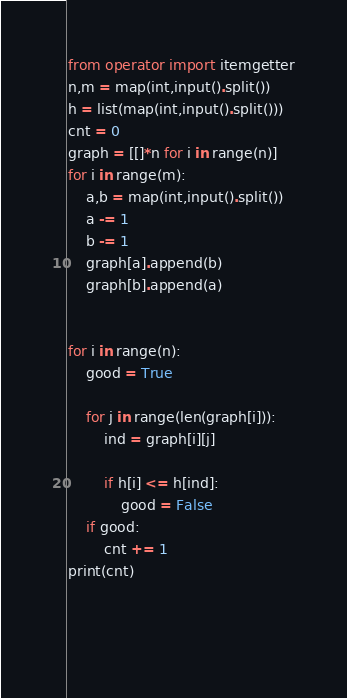<code> <loc_0><loc_0><loc_500><loc_500><_Python_>from operator import itemgetter
n,m = map(int,input().split())
h = list(map(int,input().split()))
cnt = 0
graph = [[]*n for i in range(n)]
for i in range(m):
    a,b = map(int,input().split())
    a -= 1
    b -= 1
    graph[a].append(b)
    graph[b].append(a)


for i in range(n):
    good = True
    
    for j in range(len(graph[i])):
        ind = graph[i][j]
        
        if h[i] <= h[ind]:
            good = False
    if good:
        cnt += 1
print(cnt)

        
        

</code> 